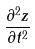Convert formula to latex. <formula><loc_0><loc_0><loc_500><loc_500>\frac { \partial ^ { 2 } z } { \partial t ^ { 2 } }</formula> 